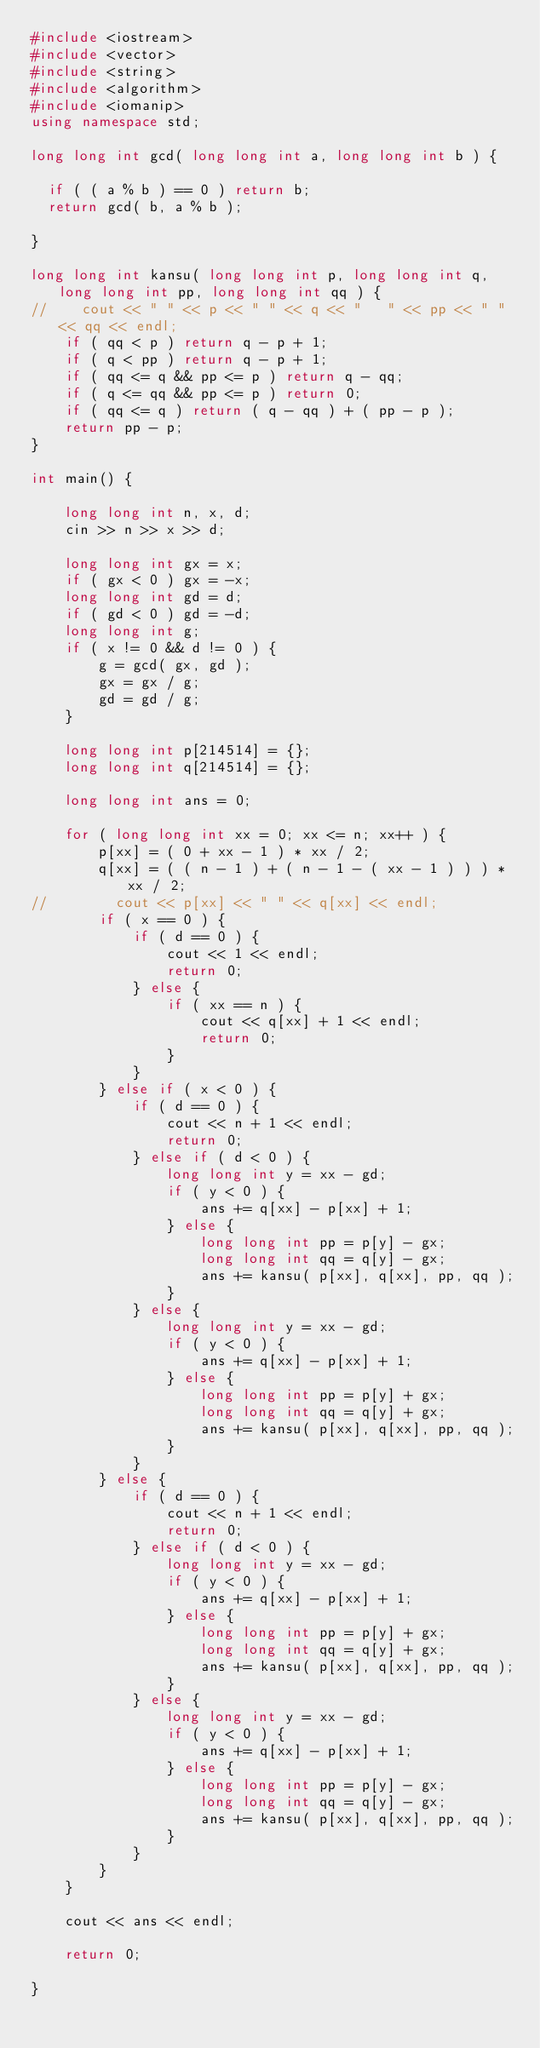<code> <loc_0><loc_0><loc_500><loc_500><_C++_>#include <iostream>
#include <vector>
#include <string>
#include <algorithm>
#include <iomanip>
using namespace std;

long long int gcd( long long int a, long long int b ) {

  if ( ( a % b ) == 0 ) return b;
  return gcd( b, a % b );

}

long long int kansu( long long int p, long long int q, long long int pp, long long int qq ) {
//    cout << " " << p << " " << q << "   " << pp << " " << qq << endl;
    if ( qq < p ) return q - p + 1;
    if ( q < pp ) return q - p + 1;
    if ( qq <= q && pp <= p ) return q - qq;
    if ( q <= qq && pp <= p ) return 0;
    if ( qq <= q ) return ( q - qq ) + ( pp - p );
    return pp - p;
}

int main() {

    long long int n, x, d;
    cin >> n >> x >> d;

    long long int gx = x;
    if ( gx < 0 ) gx = -x;
    long long int gd = d;
    if ( gd < 0 ) gd = -d;
    long long int g;
    if ( x != 0 && d != 0 ) {
        g = gcd( gx, gd );
        gx = gx / g;
        gd = gd / g;
    }

    long long int p[214514] = {};
    long long int q[214514] = {};

    long long int ans = 0;

    for ( long long int xx = 0; xx <= n; xx++ ) {
        p[xx] = ( 0 + xx - 1 ) * xx / 2;
        q[xx] = ( ( n - 1 ) + ( n - 1 - ( xx - 1 ) ) ) * xx / 2;
//        cout << p[xx] << " " << q[xx] << endl;
        if ( x == 0 ) {
            if ( d == 0 ) {
                cout << 1 << endl;
                return 0;
            } else {
                if ( xx == n ) {
                    cout << q[xx] + 1 << endl;
                    return 0;
                }
            }
        } else if ( x < 0 ) {
            if ( d == 0 ) {
                cout << n + 1 << endl;
                return 0;
            } else if ( d < 0 ) {
                long long int y = xx - gd;
                if ( y < 0 ) {
                    ans += q[xx] - p[xx] + 1;
                } else {
                    long long int pp = p[y] - gx;
                    long long int qq = q[y] - gx;
                    ans += kansu( p[xx], q[xx], pp, qq );
                }
            } else {
                long long int y = xx - gd;
                if ( y < 0 ) {
                    ans += q[xx] - p[xx] + 1;
                } else {
                    long long int pp = p[y] + gx;
                    long long int qq = q[y] + gx;
                    ans += kansu( p[xx], q[xx], pp, qq );
                }
            }
        } else {
            if ( d == 0 ) {
                cout << n + 1 << endl;
                return 0;
            } else if ( d < 0 ) {
                long long int y = xx - gd;
                if ( y < 0 ) {
                    ans += q[xx] - p[xx] + 1;
                } else {
                    long long int pp = p[y] + gx;
                    long long int qq = q[y] + gx;
                    ans += kansu( p[xx], q[xx], pp, qq );
                }
            } else {
                long long int y = xx - gd;
                if ( y < 0 ) {
                    ans += q[xx] - p[xx] + 1;
                } else {
                    long long int pp = p[y] - gx;
                    long long int qq = q[y] - gx;
                    ans += kansu( p[xx], q[xx], pp, qq );
                }
            }
        }
    }

    cout << ans << endl;

    return 0;

}
</code> 